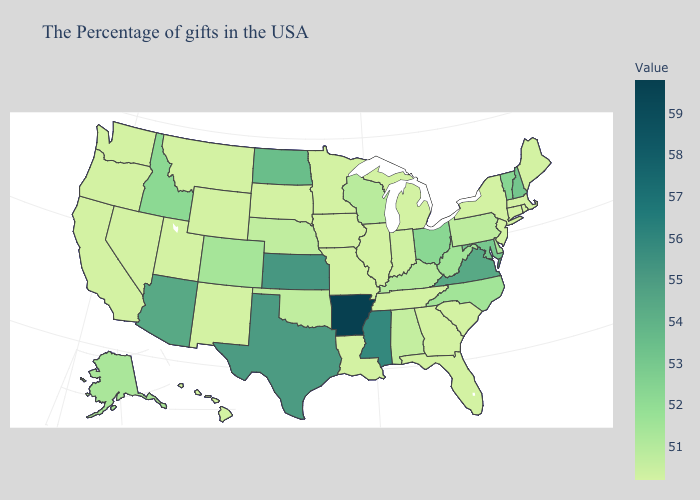Does Kansas have the highest value in the MidWest?
Be succinct. Yes. Among the states that border Indiana , does Michigan have the lowest value?
Write a very short answer. Yes. Among the states that border New Hampshire , which have the highest value?
Write a very short answer. Vermont. Does the map have missing data?
Be succinct. No. Which states hav the highest value in the West?
Answer briefly. Arizona. 